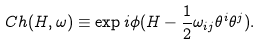<formula> <loc_0><loc_0><loc_500><loc_500>C h ( H , \omega ) \equiv \exp i \phi ( H - \frac { 1 } { 2 } \omega _ { i j } \theta ^ { i } \theta ^ { j } ) .</formula> 